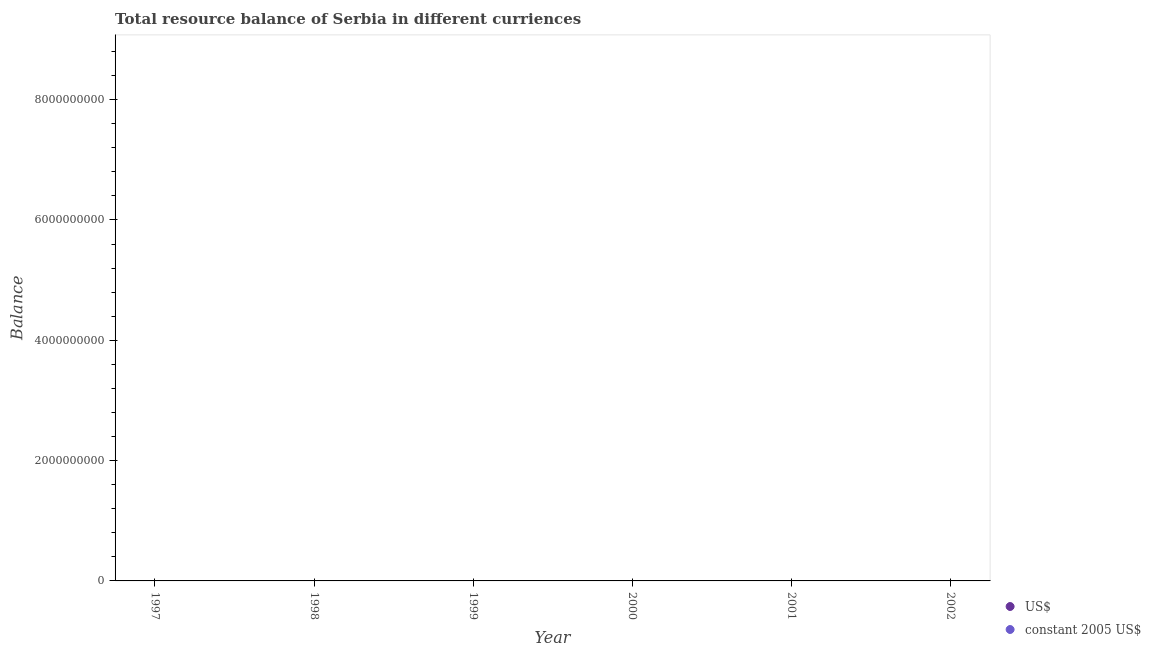How many different coloured dotlines are there?
Your answer should be compact. 0. Is the number of dotlines equal to the number of legend labels?
Your answer should be very brief. No. Across all years, what is the minimum resource balance in constant us$?
Ensure brevity in your answer.  0. What is the difference between the resource balance in us$ in 1997 and the resource balance in constant us$ in 2001?
Your response must be concise. 0. Does the resource balance in us$ monotonically increase over the years?
Make the answer very short. No. How many years are there in the graph?
Provide a succinct answer. 6. What is the difference between two consecutive major ticks on the Y-axis?
Provide a short and direct response. 2.00e+09. Are the values on the major ticks of Y-axis written in scientific E-notation?
Make the answer very short. No. Does the graph contain any zero values?
Offer a very short reply. Yes. How many legend labels are there?
Your answer should be compact. 2. What is the title of the graph?
Your response must be concise. Total resource balance of Serbia in different curriences. What is the label or title of the Y-axis?
Your answer should be very brief. Balance. What is the Balance of constant 2005 US$ in 1998?
Offer a very short reply. 0. What is the Balance of constant 2005 US$ in 1999?
Give a very brief answer. 0. What is the Balance of constant 2005 US$ in 2000?
Make the answer very short. 0. What is the Balance of constant 2005 US$ in 2001?
Your response must be concise. 0. What is the total Balance in constant 2005 US$ in the graph?
Give a very brief answer. 0. What is the average Balance in constant 2005 US$ per year?
Provide a succinct answer. 0. 